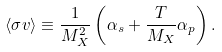<formula> <loc_0><loc_0><loc_500><loc_500>\langle \sigma v \rangle \equiv \frac { 1 } { M _ { X } ^ { 2 } } \left ( \alpha _ { s } + \frac { T } { M _ { X } } \alpha _ { p } \right ) .</formula> 